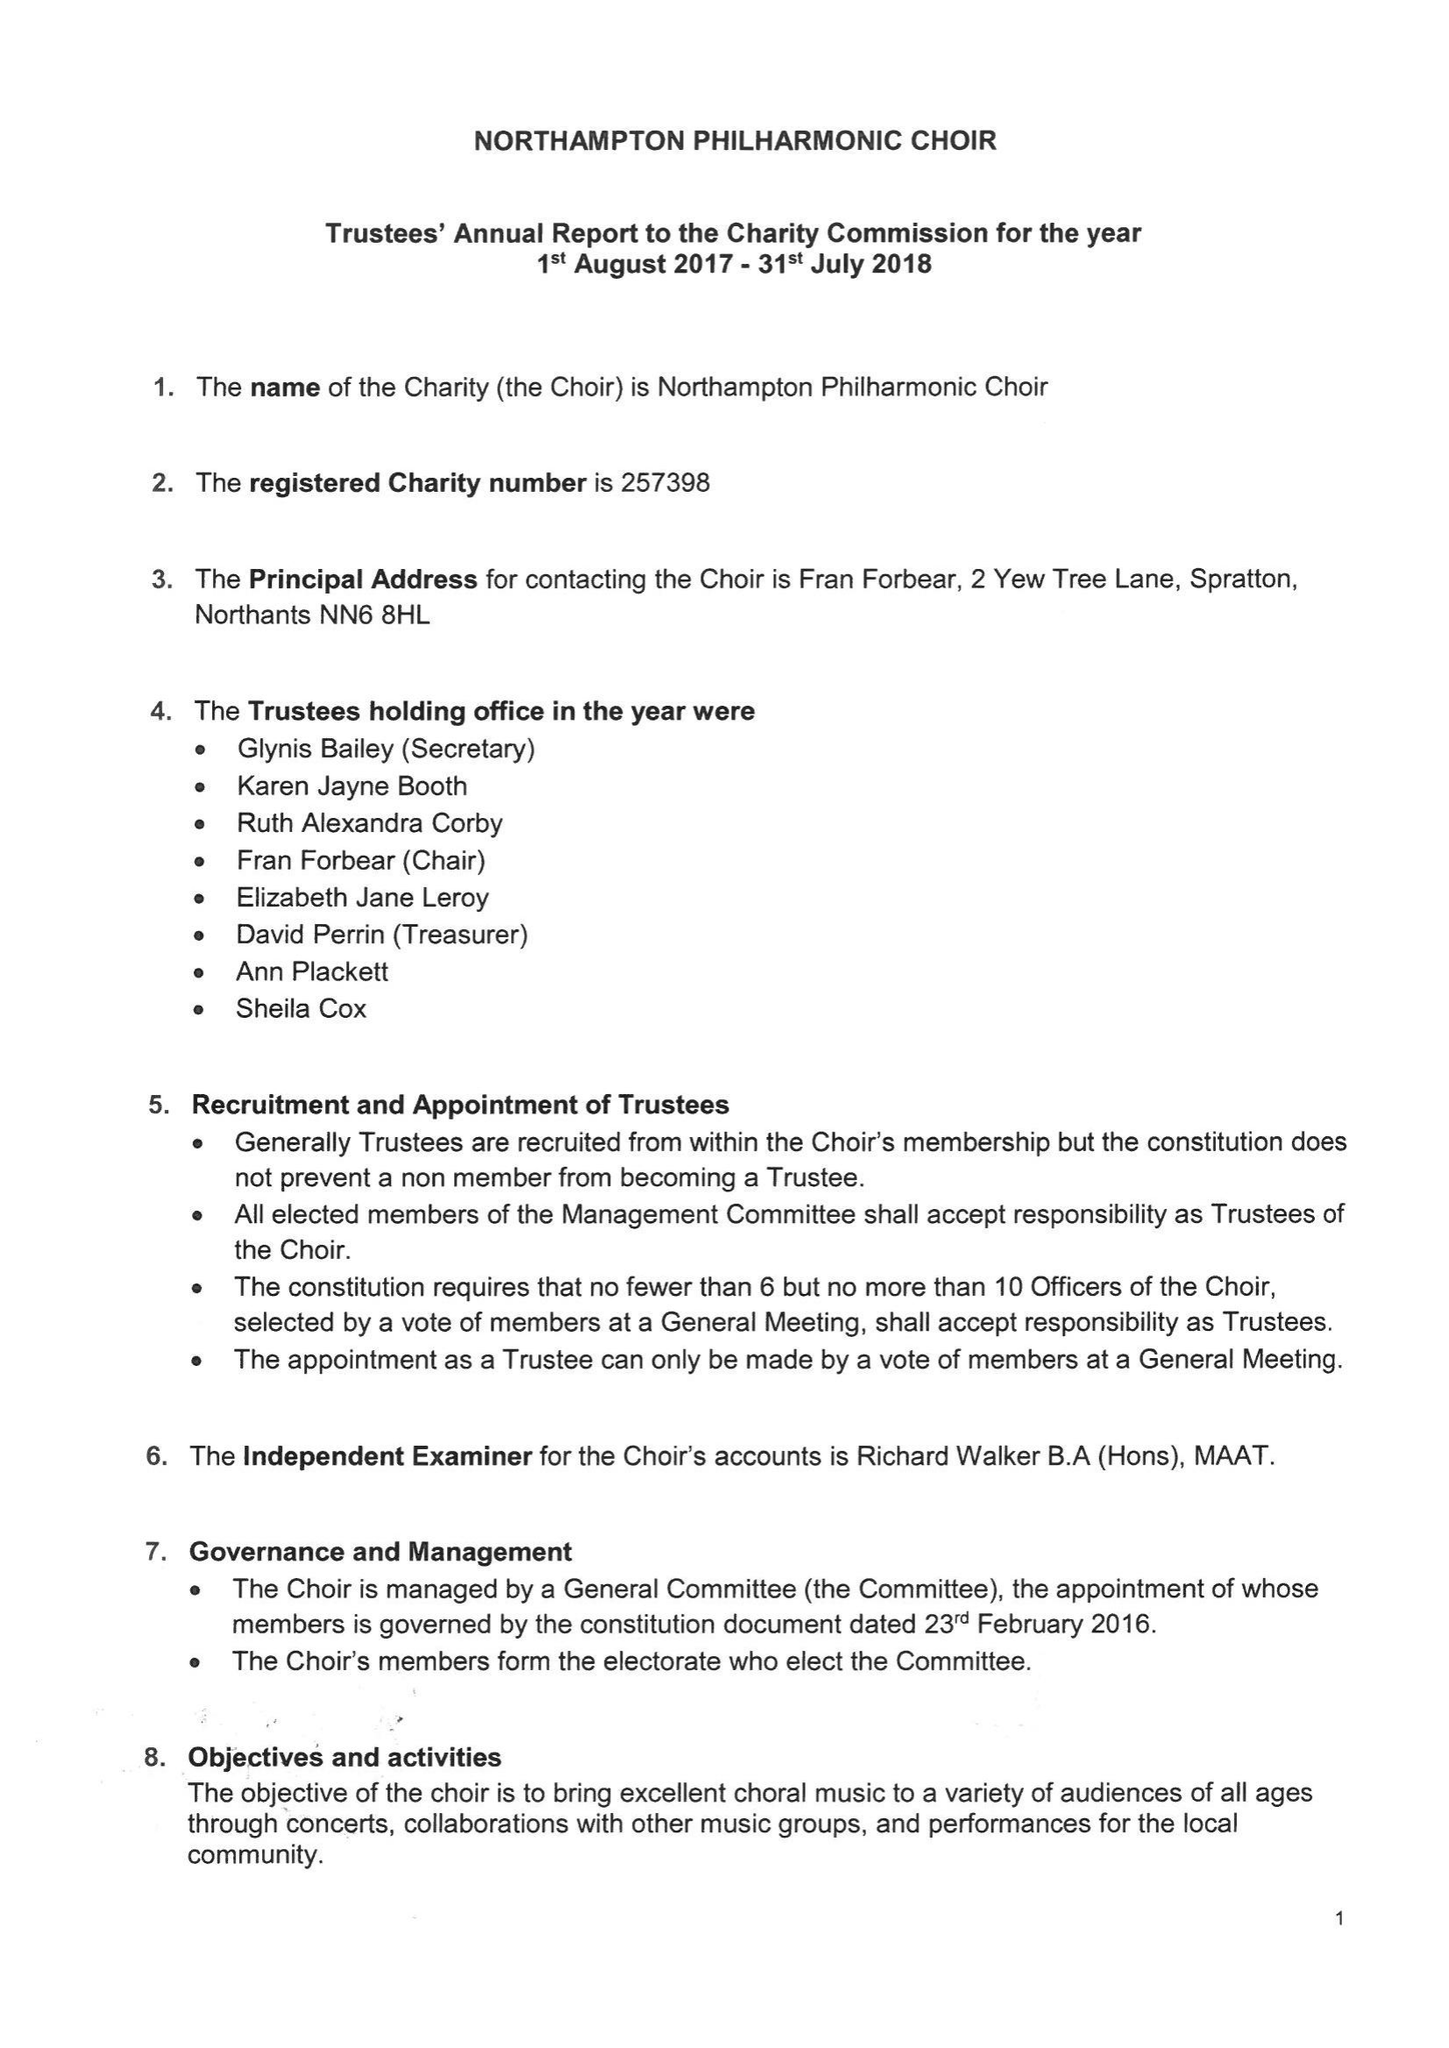What is the value for the address__post_town?
Answer the question using a single word or phrase. NORTHAMPTON 